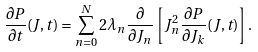Convert formula to latex. <formula><loc_0><loc_0><loc_500><loc_500>\frac { \partial P } { \partial t } ( J , t ) = \sum _ { n = 0 } ^ { N } 2 \lambda _ { n } \frac { \partial } { \partial J _ { n } } \left [ J _ { n } ^ { 2 } \frac { \partial P } { \partial J _ { k } } ( J , t ) \right ] .</formula> 